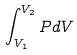<formula> <loc_0><loc_0><loc_500><loc_500>\int _ { V _ { 1 } } ^ { V _ { 2 } } P d V</formula> 